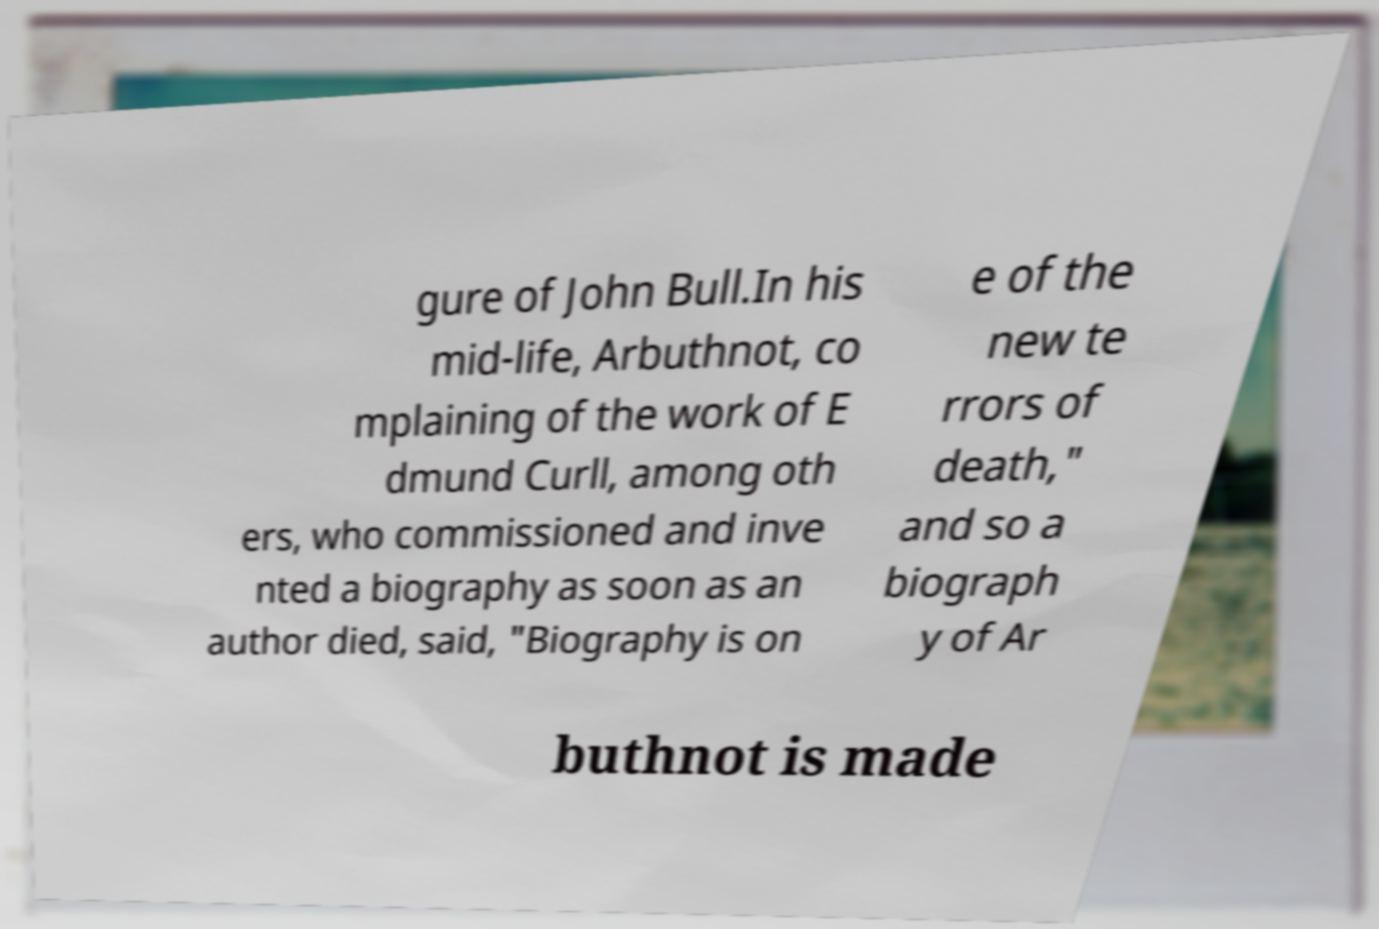Can you read and provide the text displayed in the image?This photo seems to have some interesting text. Can you extract and type it out for me? gure of John Bull.In his mid-life, Arbuthnot, co mplaining of the work of E dmund Curll, among oth ers, who commissioned and inve nted a biography as soon as an author died, said, "Biography is on e of the new te rrors of death," and so a biograph y of Ar buthnot is made 